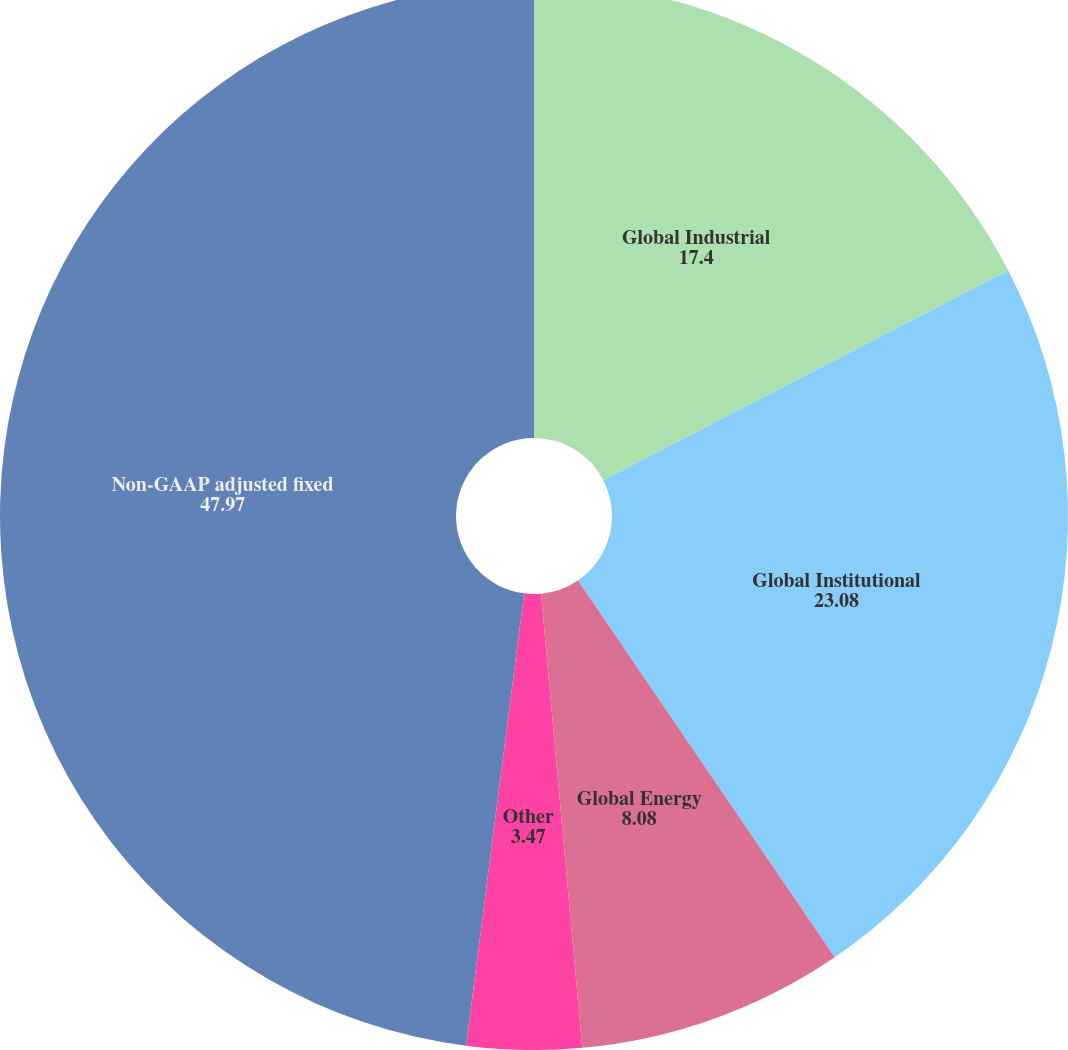Convert chart. <chart><loc_0><loc_0><loc_500><loc_500><pie_chart><fcel>Global Industrial<fcel>Global Institutional<fcel>Global Energy<fcel>Other<fcel>Non-GAAP adjusted fixed<nl><fcel>17.4%<fcel>23.08%<fcel>8.08%<fcel>3.47%<fcel>47.97%<nl></chart> 